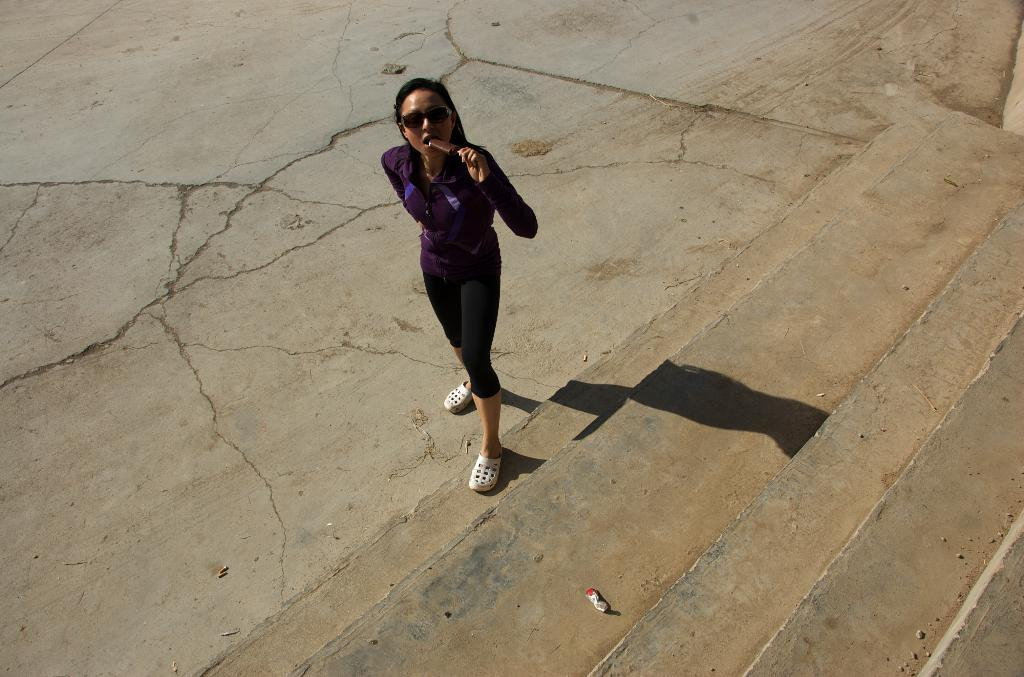What is the perspective of the image? The image shows a top view of a girl. What color is the girl's top? The girl is wearing a purple top. What type of pants is the girl wearing? The girl is wearing black track pants. What is the girl doing in the image? The girl is eating ice cream. What is the surface in front of the girl? There are concrete steps in front of the girl. What type of iron can be seen in the image? There is no iron present in the image. Are there any jellyfish visible in the image? There are no jellyfish present in the image. 